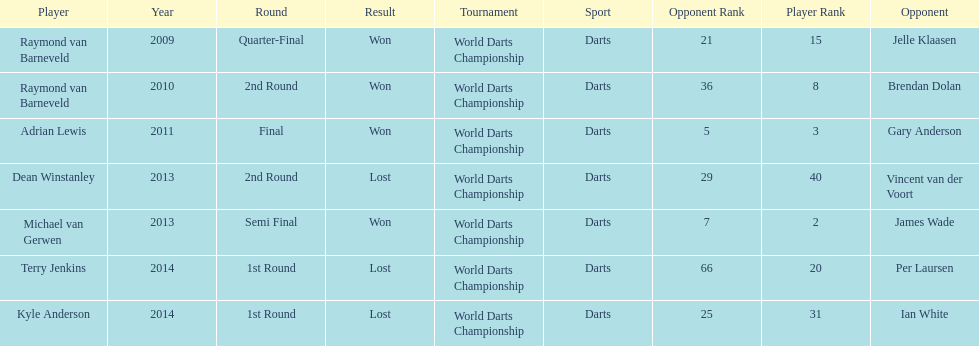Who are the only players listed that played in 2011? Adrian Lewis. 